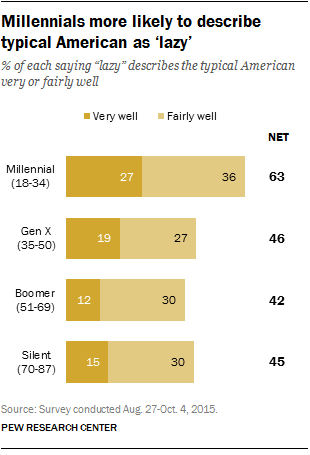Highlight a few significant elements in this photo. I would like to know the frequency of the bar with a value of 30, from data points 2 to... According to a recent survey, 27% of Millennials (18-34 years old) believe that the term "lazy" accurately describes the typical American. 